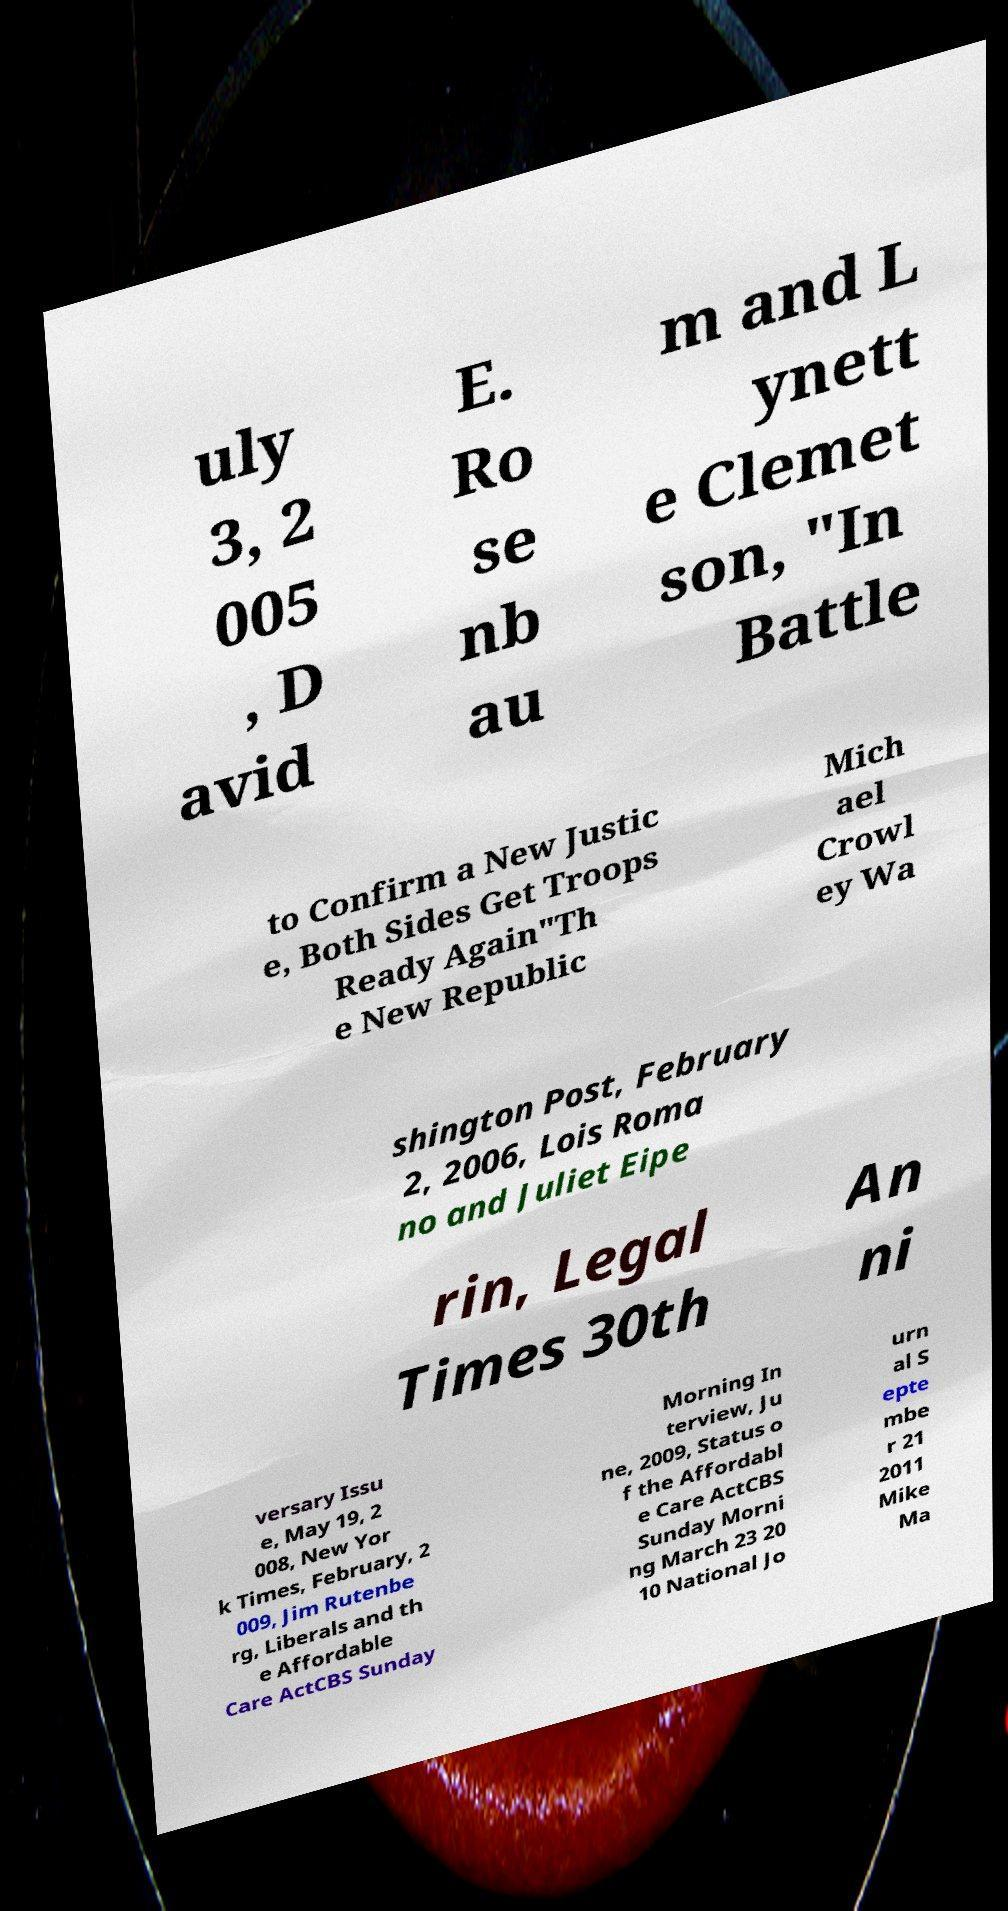Could you assist in decoding the text presented in this image and type it out clearly? uly 3, 2 005 , D avid E. Ro se nb au m and L ynett e Clemet son, "In Battle to Confirm a New Justic e, Both Sides Get Troops Ready Again"Th e New Republic Mich ael Crowl ey Wa shington Post, February 2, 2006, Lois Roma no and Juliet Eipe rin, Legal Times 30th An ni versary Issu e, May 19, 2 008, New Yor k Times, February, 2 009, Jim Rutenbe rg, Liberals and th e Affordable Care ActCBS Sunday Morning In terview, Ju ne, 2009, Status o f the Affordabl e Care ActCBS Sunday Morni ng March 23 20 10 National Jo urn al S epte mbe r 21 2011 Mike Ma 